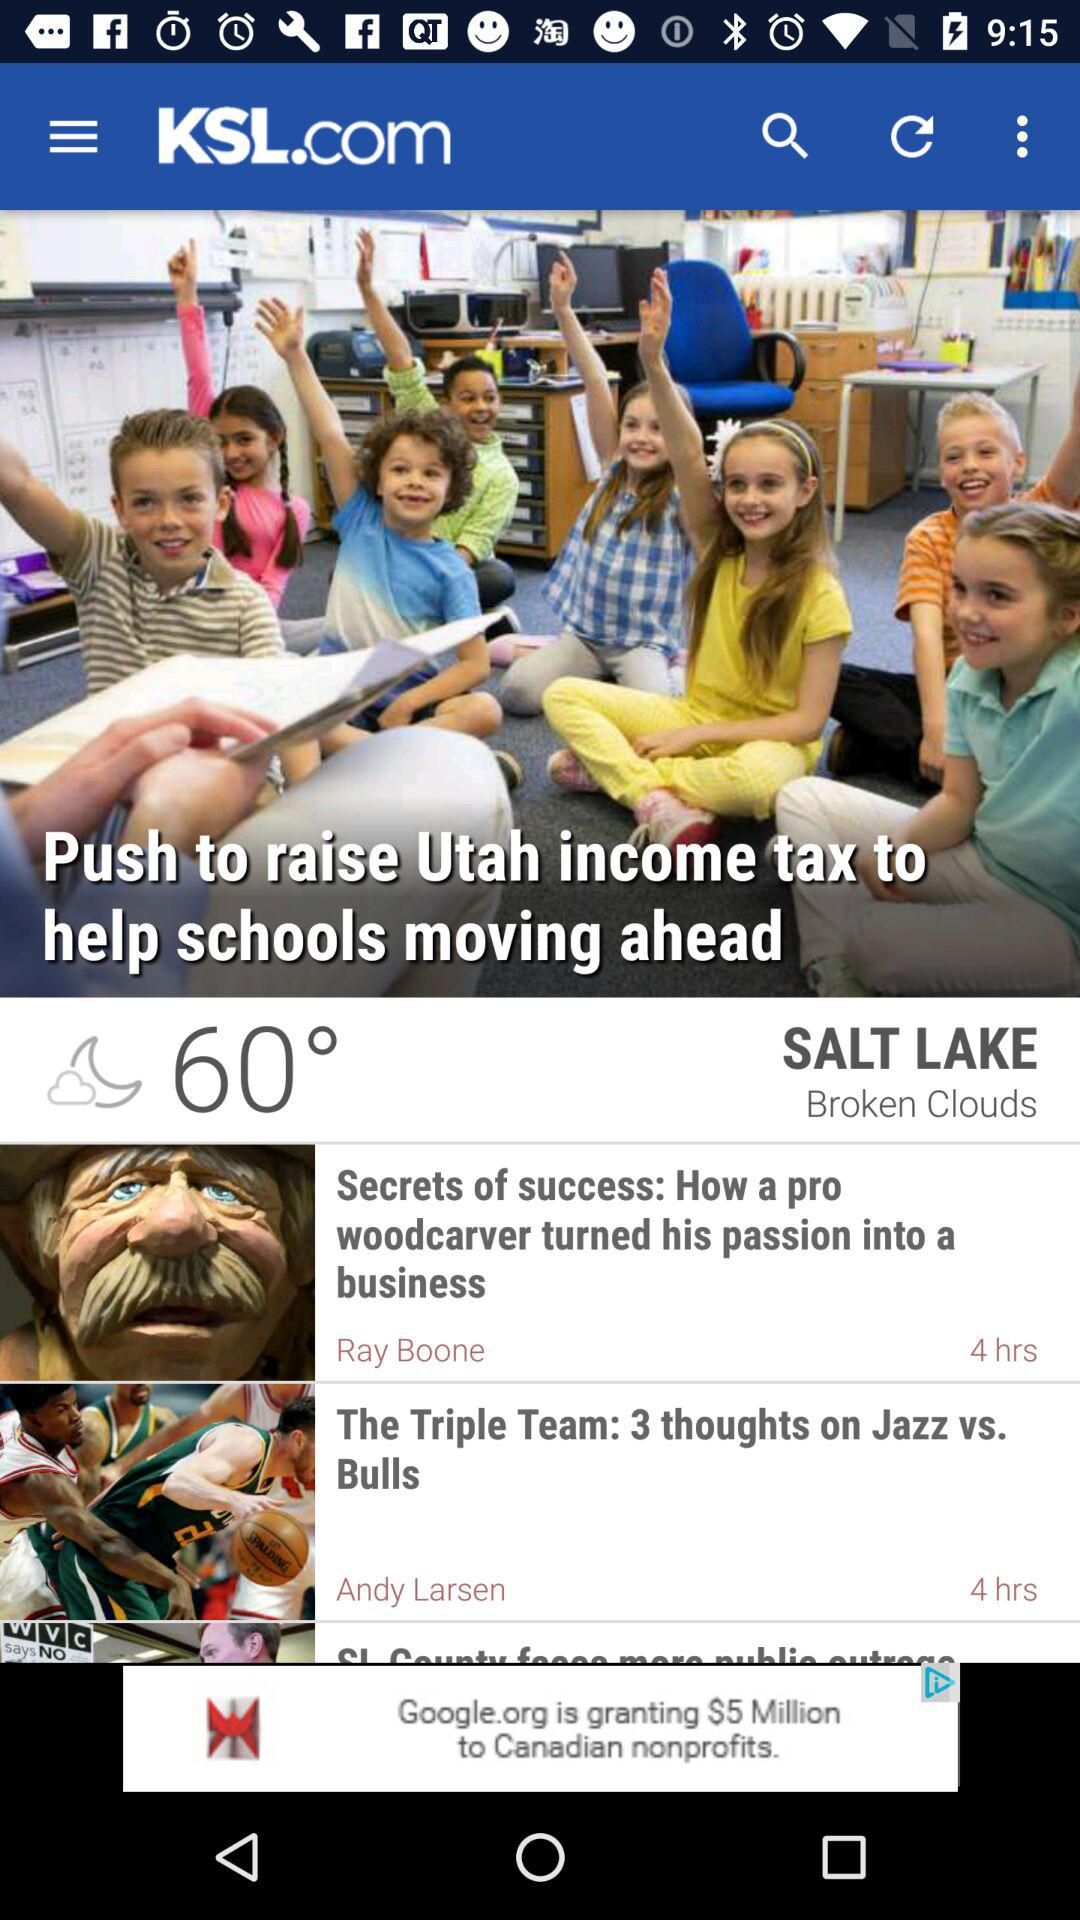How many hours ago was "The Triple Team: 3 thoughts on Jazz vs. Bulls" posted? "The Triple Team: 3 thoughts on Jazz vs. Bulls" was posted 4 hours ago. 